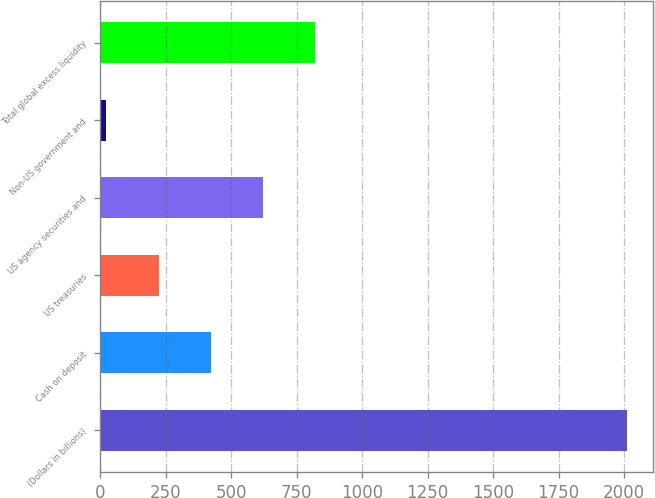<chart> <loc_0><loc_0><loc_500><loc_500><bar_chart><fcel>(Dollars in billions)<fcel>Cash on deposit<fcel>US treasuries<fcel>US agency securities and<fcel>Non-US government and<fcel>Total global excess liquidity<nl><fcel>2011<fcel>420.6<fcel>221.8<fcel>619.4<fcel>23<fcel>818.2<nl></chart> 